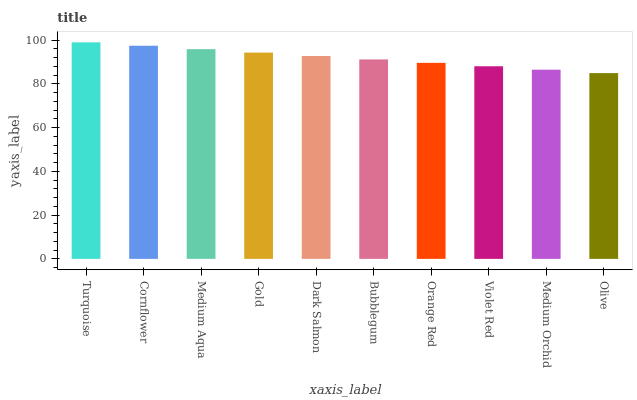Is Olive the minimum?
Answer yes or no. Yes. Is Turquoise the maximum?
Answer yes or no. Yes. Is Cornflower the minimum?
Answer yes or no. No. Is Cornflower the maximum?
Answer yes or no. No. Is Turquoise greater than Cornflower?
Answer yes or no. Yes. Is Cornflower less than Turquoise?
Answer yes or no. Yes. Is Cornflower greater than Turquoise?
Answer yes or no. No. Is Turquoise less than Cornflower?
Answer yes or no. No. Is Dark Salmon the high median?
Answer yes or no. Yes. Is Bubblegum the low median?
Answer yes or no. Yes. Is Medium Orchid the high median?
Answer yes or no. No. Is Orange Red the low median?
Answer yes or no. No. 